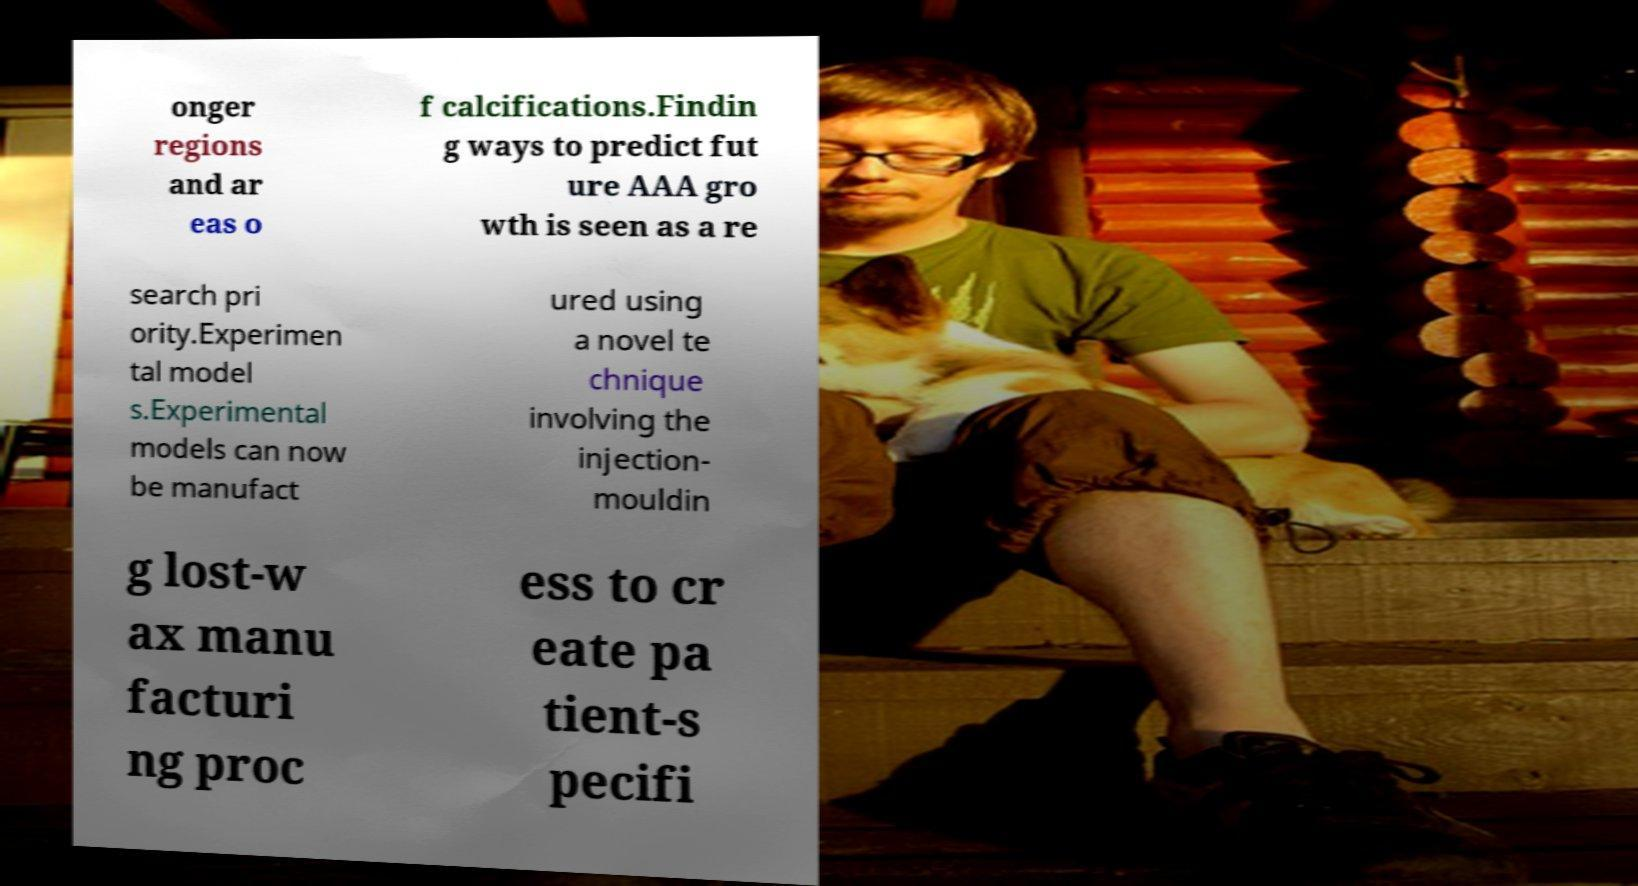Please identify and transcribe the text found in this image. onger regions and ar eas o f calcifications.Findin g ways to predict fut ure AAA gro wth is seen as a re search pri ority.Experimen tal model s.Experimental models can now be manufact ured using a novel te chnique involving the injection- mouldin g lost-w ax manu facturi ng proc ess to cr eate pa tient-s pecifi 